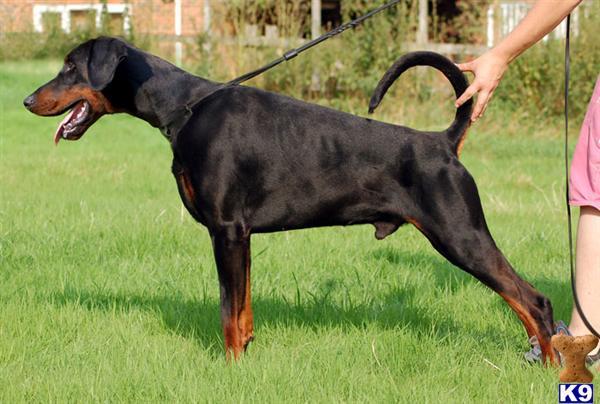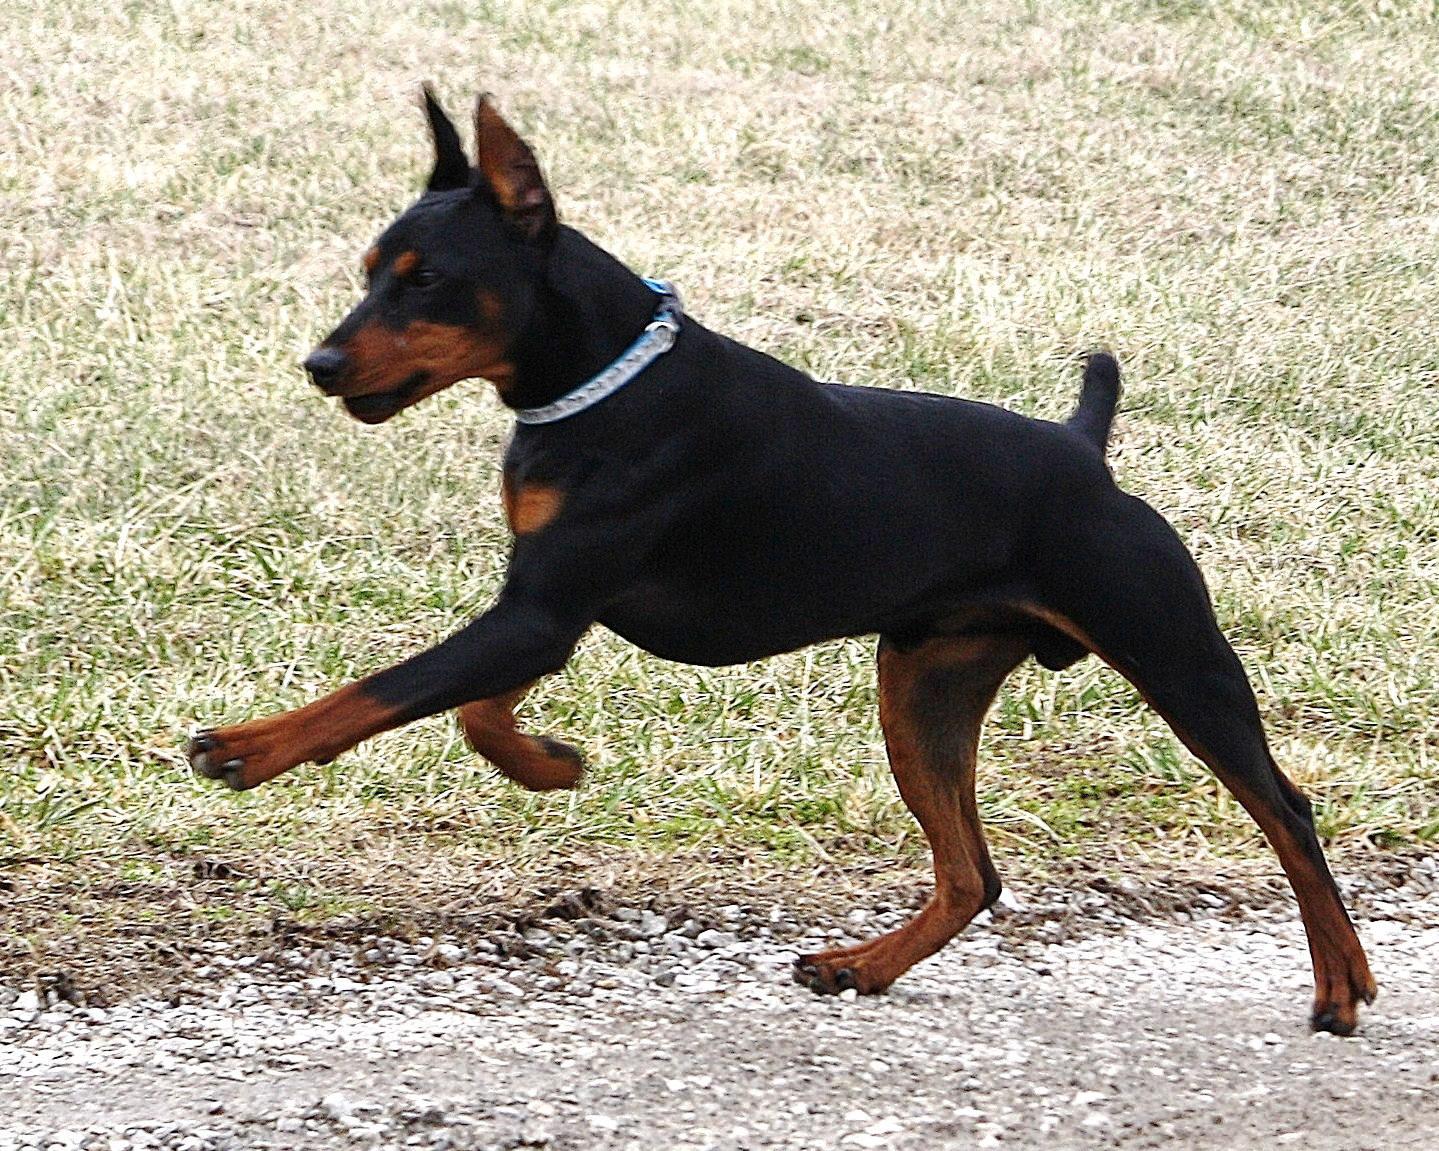The first image is the image on the left, the second image is the image on the right. Considering the images on both sides, is "One dog's tail is docked; the other dog's tail is normal." valid? Answer yes or no. Yes. The first image is the image on the left, the second image is the image on the right. For the images shown, is this caption "The left image shows a floppy-eared doberman standing with its undocked tail curled upward, and the right image shows a doberman with pointy erect ears and a docked tail who is standing up." true? Answer yes or no. Yes. 